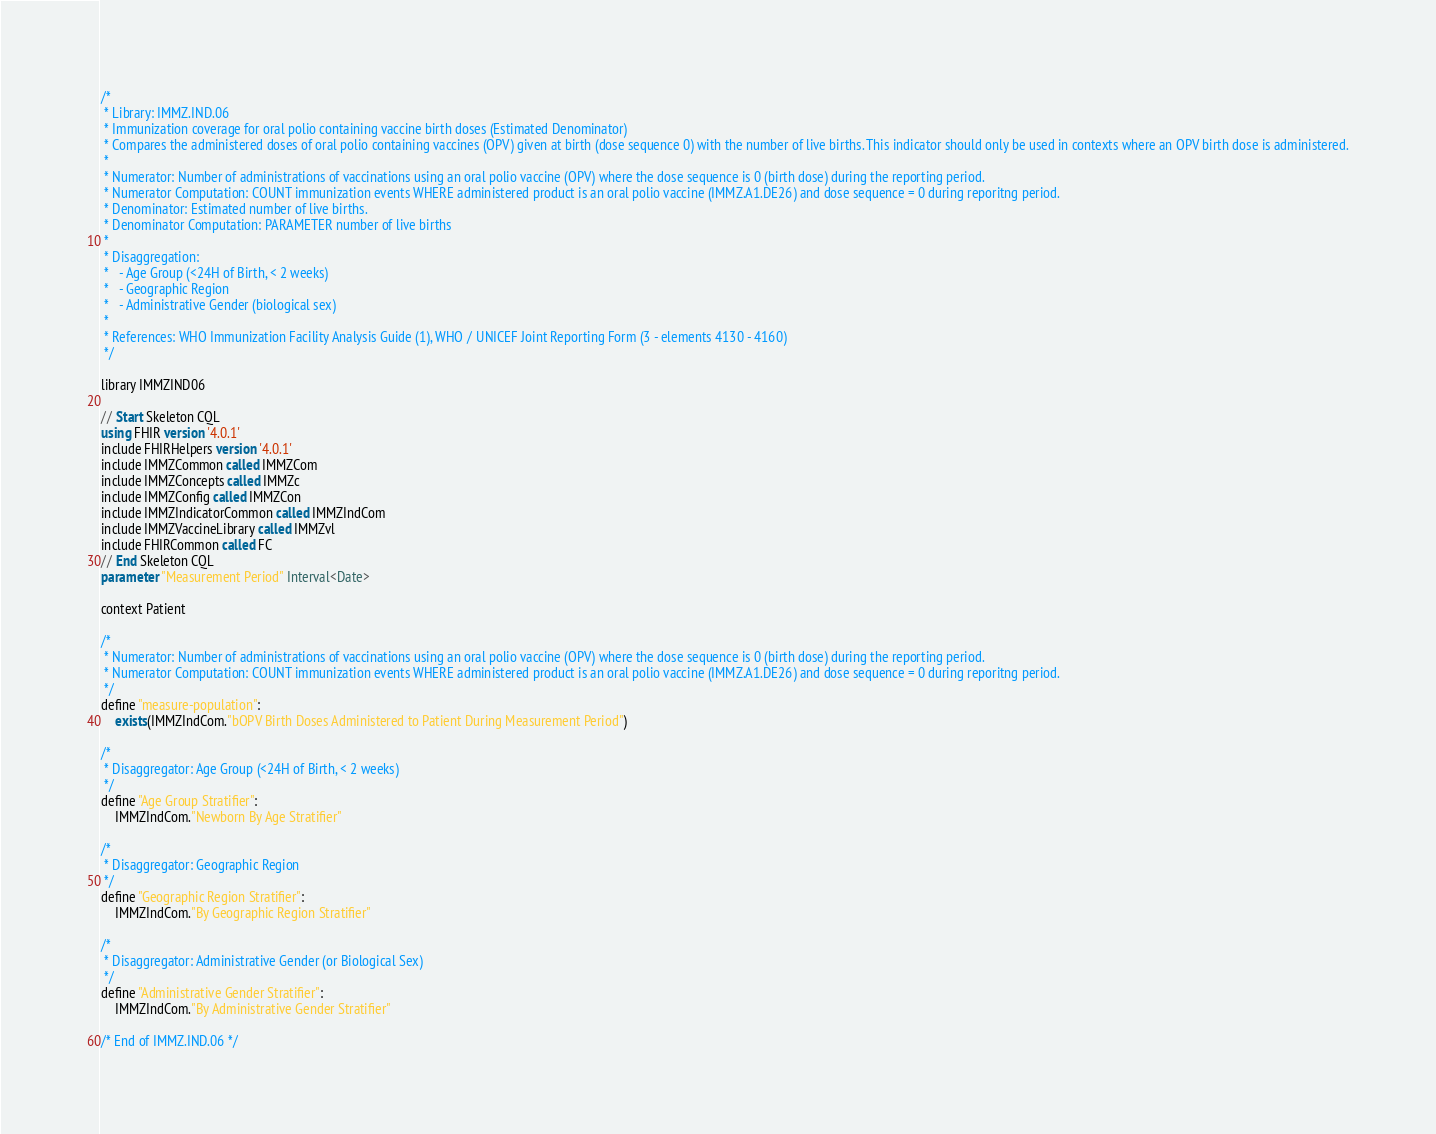Convert code to text. <code><loc_0><loc_0><loc_500><loc_500><_SQL_>/*
 * Library: IMMZ.IND.06
 * Immunization coverage for oral polio containing vaccine birth doses (Estimated Denominator) 
 * Compares the administered doses of oral polio containing vaccines (OPV) given at birth (dose sequence 0) with the number of live births. This indicator should only be used in contexts where an OPV birth dose is administered.
 * 
 * Numerator: Number of administrations of vaccinations using an oral polio vaccine (OPV) where the dose sequence is 0 (birth dose) during the reporting period. 
 * Numerator Computation: COUNT immunization events WHERE administered product is an oral polio vaccine (IMMZ.A1.DE26) and dose sequence = 0 during reporitng period.
 * Denominator: Estimated number of live births.
 * Denominator Computation: PARAMETER number of live births
 * 
 * Disaggregation:
 *   - Age Group (<24H of Birth, < 2 weeks)
 *   - Geographic Region
 *   - Administrative Gender (biological sex)
 * 
 * References: WHO Immunization Facility Analysis Guide (1), WHO / UNICEF Joint Reporting Form (3 - elements 4130 - 4160)
 */

library IMMZIND06

// Start Skeleton CQL
using FHIR version '4.0.1'
include FHIRHelpers version '4.0.1'
include IMMZCommon called IMMZCom
include IMMZConcepts called IMMZc
include IMMZConfig called IMMZCon
include IMMZIndicatorCommon called IMMZIndCom
include IMMZVaccineLibrary called IMMZvl
include FHIRCommon called FC
// End Skeleton CQL
parameter "Measurement Period" Interval<Date>

context Patient

/*
 * Numerator: Number of administrations of vaccinations using an oral polio vaccine (OPV) where the dose sequence is 0 (birth dose) during the reporting period.
 * Numerator Computation: COUNT immunization events WHERE administered product is an oral polio vaccine (IMMZ.A1.DE26) and dose sequence = 0 during reporitng period.
 */
define "measure-population":
	exists(IMMZIndCom."bOPV Birth Doses Administered to Patient During Measurement Period")

/*
 * Disaggregator: Age Group (<24H of Birth, < 2 weeks)
 */
define "Age Group Stratifier":
	IMMZIndCom."Newborn By Age Stratifier"

/*
 * Disaggregator: Geographic Region
 */
define "Geographic Region Stratifier":
	IMMZIndCom."By Geographic Region Stratifier"

/*
 * Disaggregator: Administrative Gender (or Biological Sex)
 */
define "Administrative Gender Stratifier":
	IMMZIndCom."By Administrative Gender Stratifier"

/* End of IMMZ.IND.06 */
</code> 